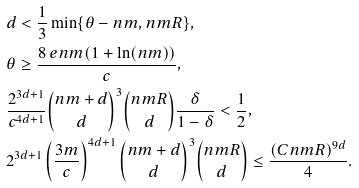<formula> <loc_0><loc_0><loc_500><loc_500>& d < \frac { 1 } { 3 } \min \{ \theta - n m , n m R \} , \\ & \theta \geq \frac { 8 \ e n m ( 1 + \ln ( n m ) ) } { c } , \\ & \frac { 2 ^ { 3 d + 1 } } { c ^ { 4 d + 1 } } \binom { n m + d } { d } ^ { 3 } \binom { n m R } { d } \frac { \delta } { 1 - \delta } < \frac { 1 } { 2 } , \\ & 2 ^ { 3 d + 1 } \left ( \frac { 3 m } { c } \right ) ^ { 4 d + 1 } \binom { n m + d } { d } ^ { 3 } \binom { n m R } { d } \leq \frac { ( C n m R ) ^ { 9 d } } { 4 } .</formula> 